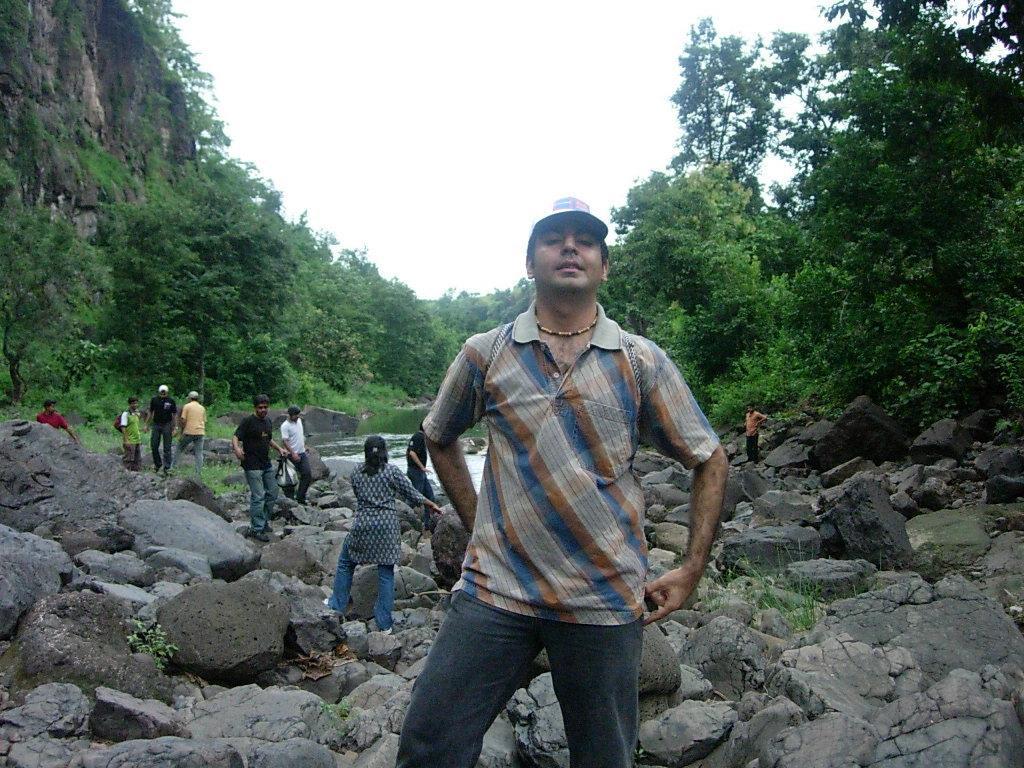Could you give a brief overview of what you see in this image? In this picture there are people and we can see rocks, plants, trees, water and hill. In the background of the image we can see the sky. 